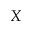Convert formula to latex. <formula><loc_0><loc_0><loc_500><loc_500>X</formula> 